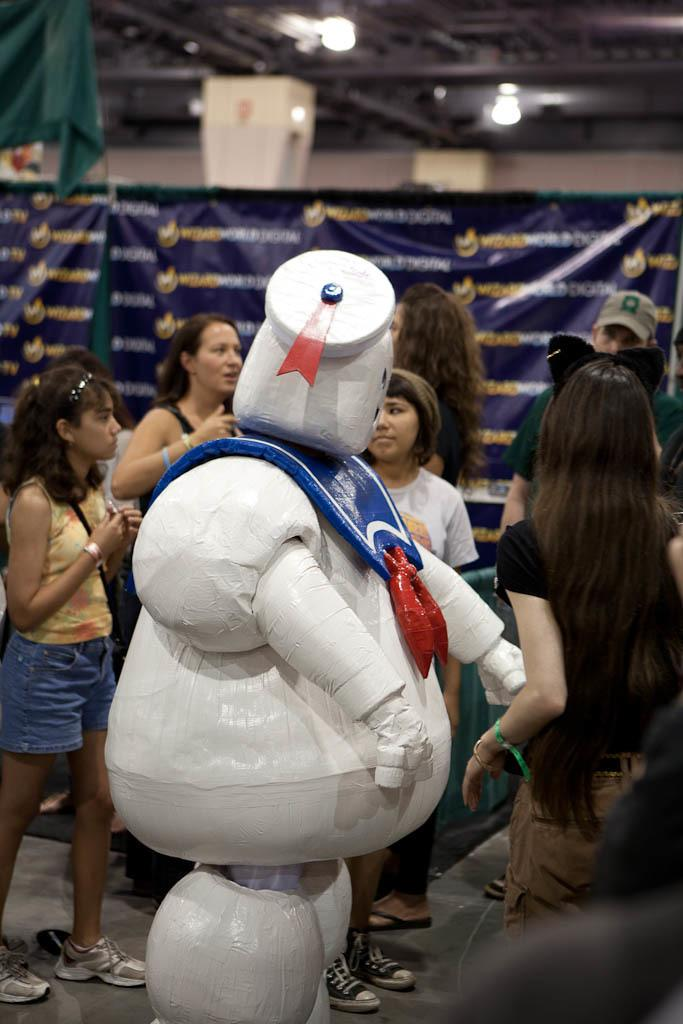What can be seen in the image involving people? There are people standing in the image. What is the banner with text used for in the image? The banner with text is likely used for communication or promotion in the image. What is the main object or structure in the middle of the image? There appears to be a statue in the middle of the image. Can you see a toothbrush being used by any of the people in the image? There is no toothbrush present in the image. Are there any jellyfish swimming around the statue in the image? There are no jellyfish present in the image. 